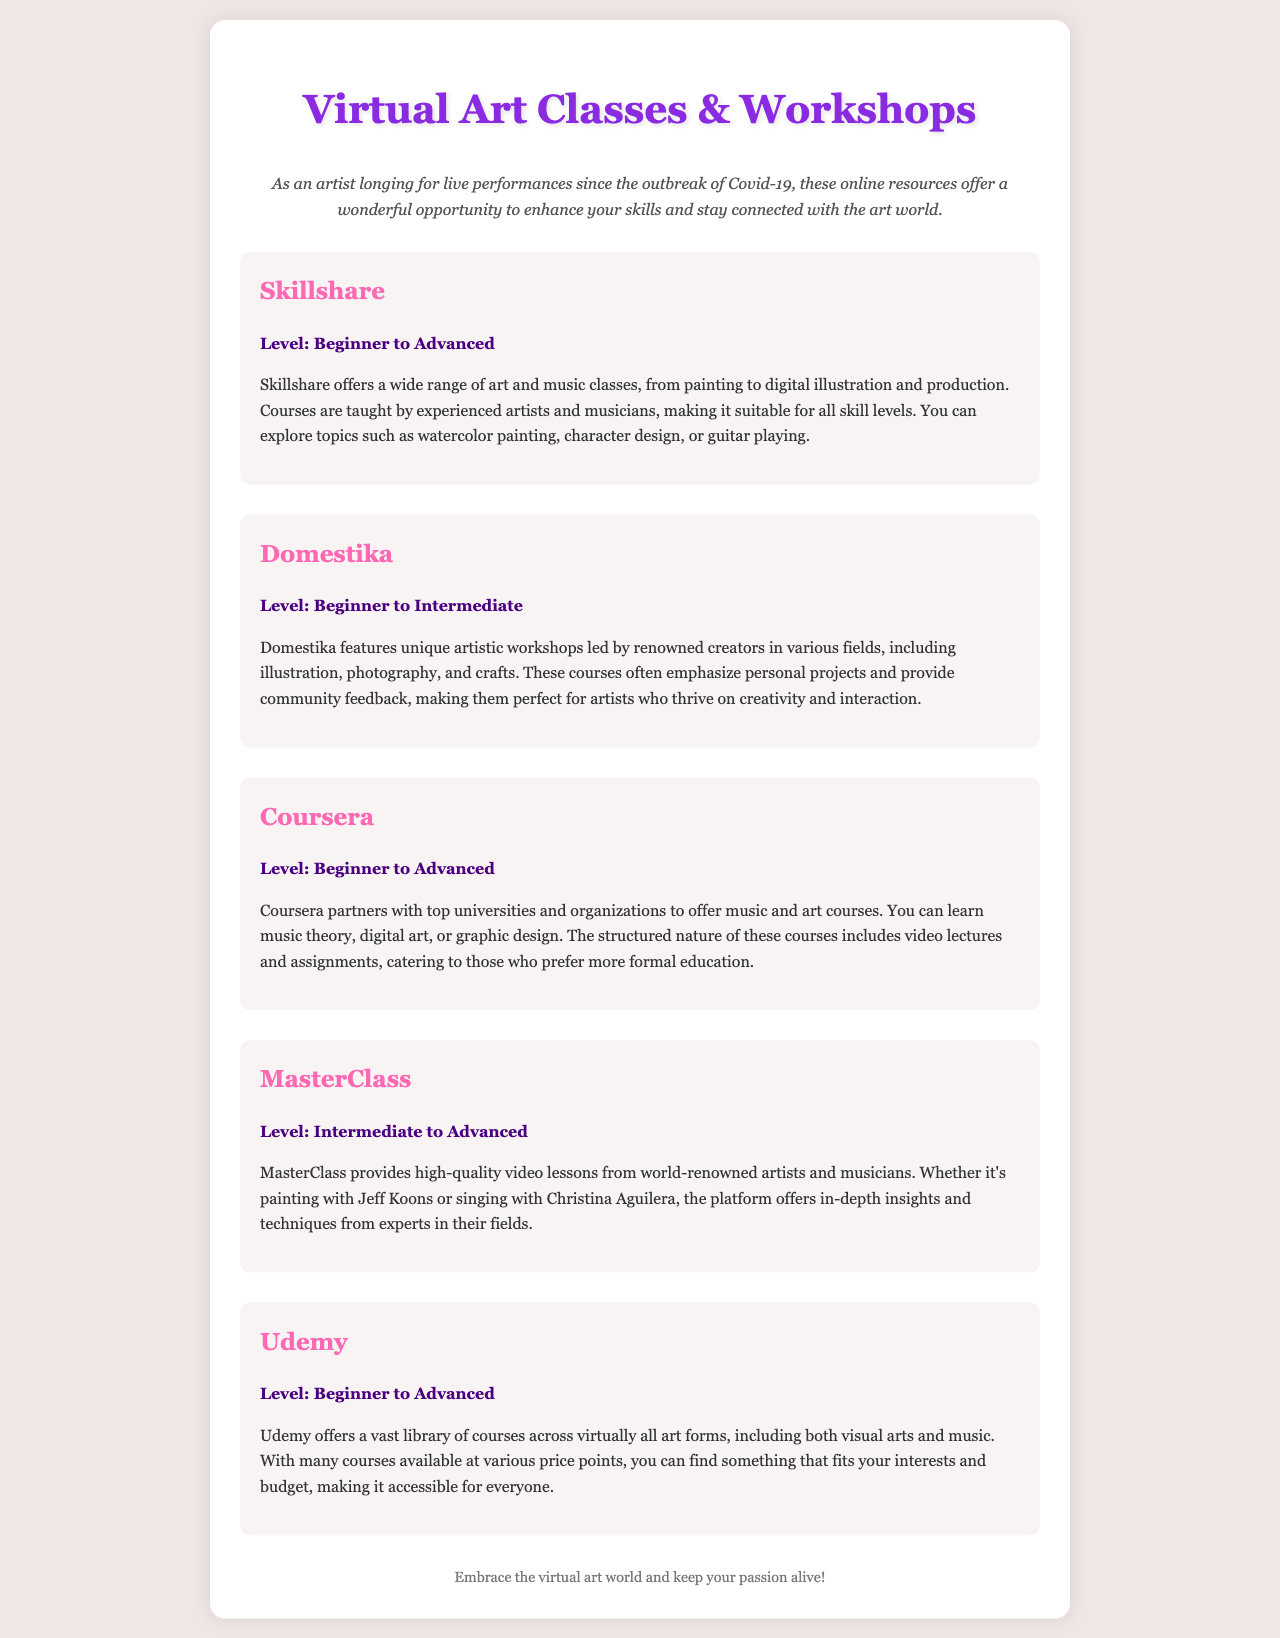What is the title of the document? The title of the document is indicated in the header section as "Virtual Art Classes Recommendations."
Answer: Virtual Art Classes Recommendations What is the introductory message for artists? The introductory message emphasizes the longing for live performances and the opportunity to enhance skills through online resources.
Answer: As an artist longing for live performances since the outbreak of Covid-19, these online resources offer a wonderful opportunity to enhance your skills and stay connected with the art world Which platform offers courses from beginner to advanced level? The document lists multiple platforms, but Skillshare specifically mentions that it offers courses suitable for all skill levels.
Answer: Skillshare What is the main focus of Domestika's workshops? Domestika's workshops emphasize personal projects and provide community feedback, catering to creative artists.
Answer: Personal projects and community feedback Who provides lessons on MasterClass? The document notes that MasterClass provides lessons from world-renowned artists and musicians.
Answer: World-renowned artists and musicians What level of expertise is required for MasterClass courses? The document states that MasterClass caters to individuals with an intermediate to advanced level of expertise.
Answer: Intermediate to Advanced Which platform features unique artistic workshops? Domestika is highlighted in the document for offering unique artistic workshops led by renowned creators.
Answer: Domestika How does Coursera deliver its courses? It mentions that Coursera offers structured courses, including video lectures and assignments, which is critical for formal education.
Answer: Video lectures and assignments 